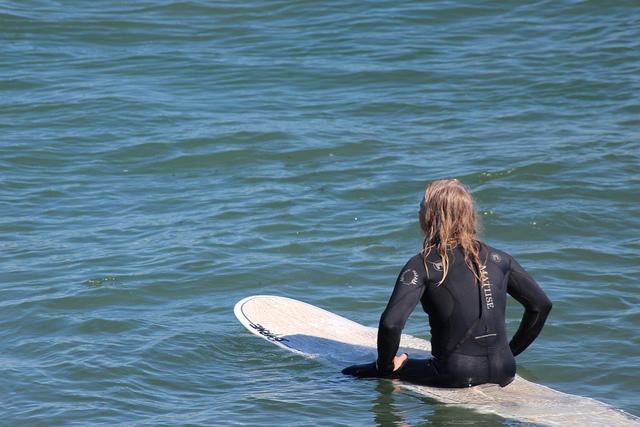Is the person facing us?
Answer briefly. No. What color is the surfboard?
Answer briefly. White. Is the woman's hair tied up or down?
Keep it brief. Down. 